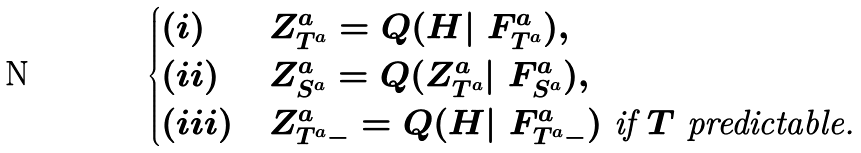<formula> <loc_0><loc_0><loc_500><loc_500>\begin{cases} ( i ) & Z _ { T ^ { a } } ^ { a } = Q ( H | \ F _ { T ^ { a } } ^ { a } ) , \\ ( i i ) & Z _ { S ^ { a } } ^ { a } = Q ( Z _ { T ^ { a } } ^ { a } | \ F _ { S ^ { a } } ^ { a } ) , \\ ( i i i ) & Z _ { T ^ { a } - } ^ { a } = Q ( H | \ F _ { T ^ { a } - } ^ { a } ) \text { if } T \text { predictable.} \end{cases}</formula> 